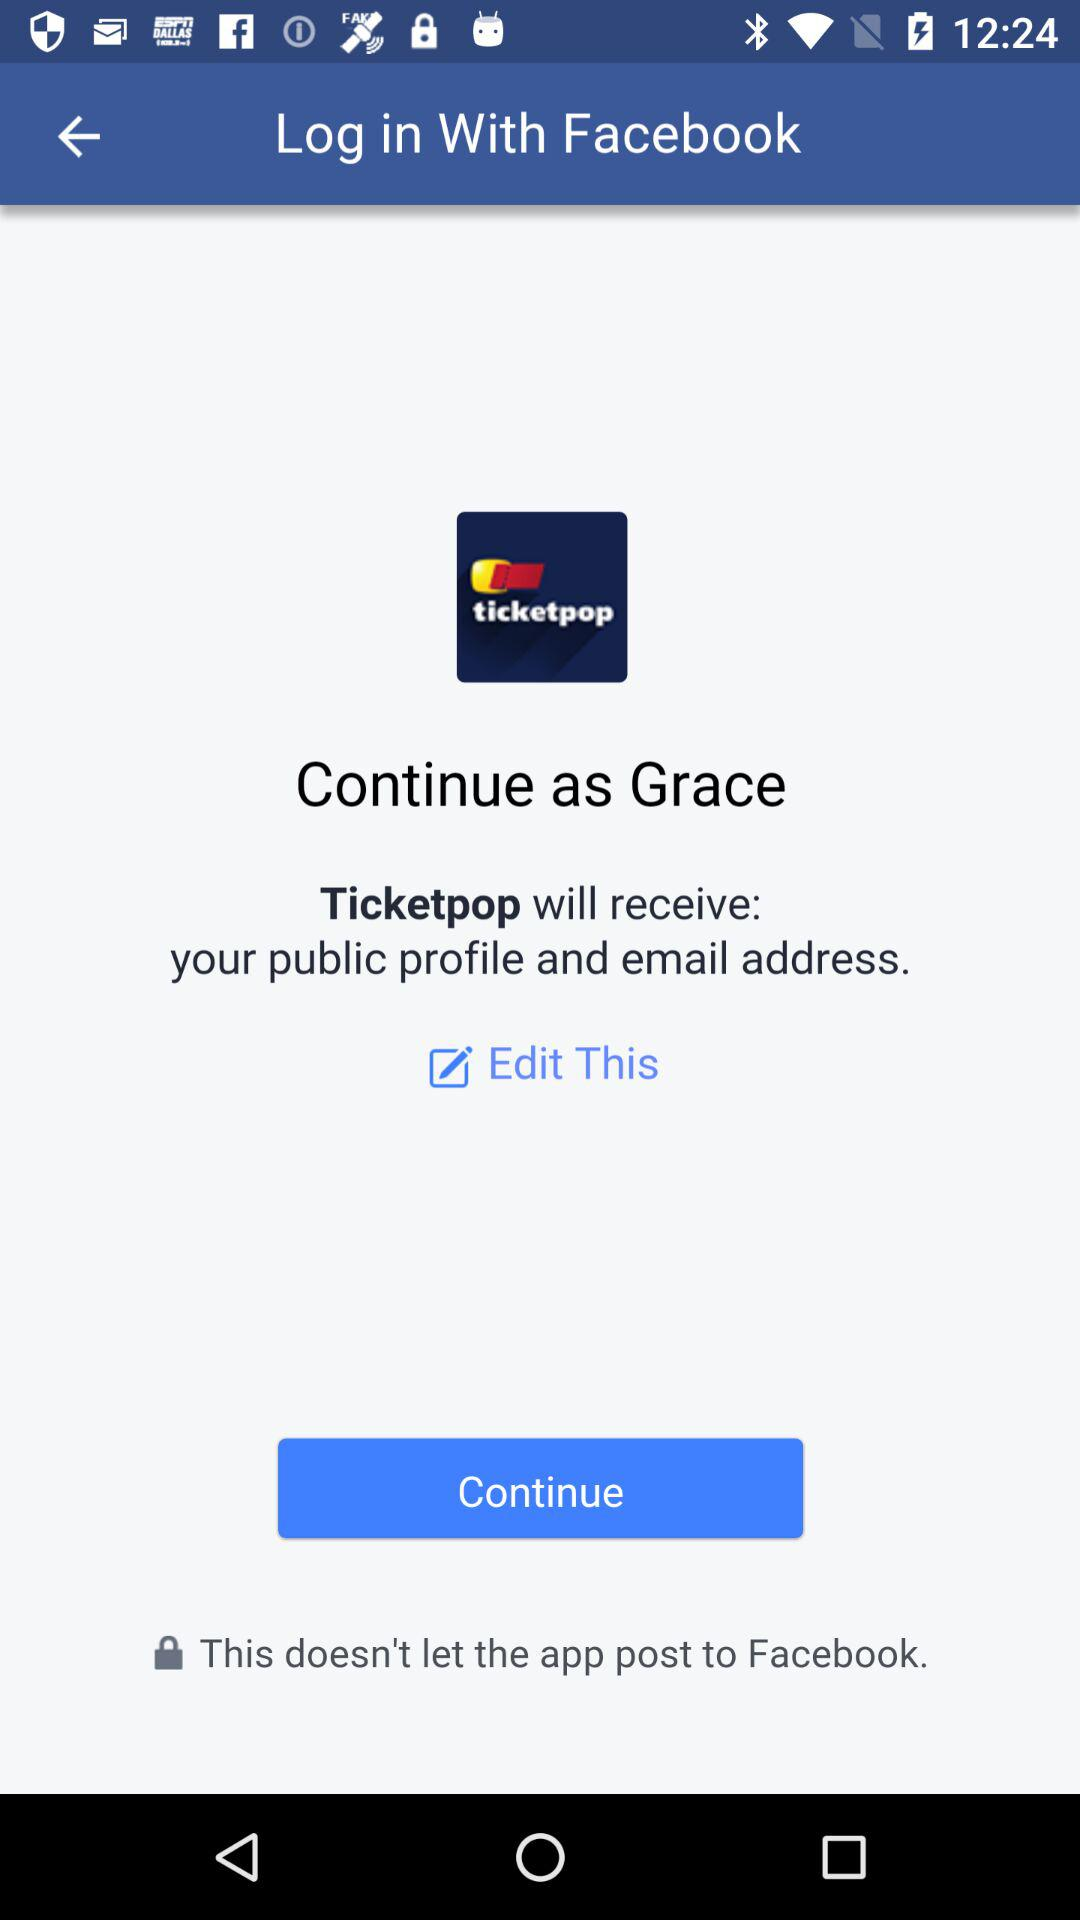What is the user name to continue the profile? The user name is Grace. 